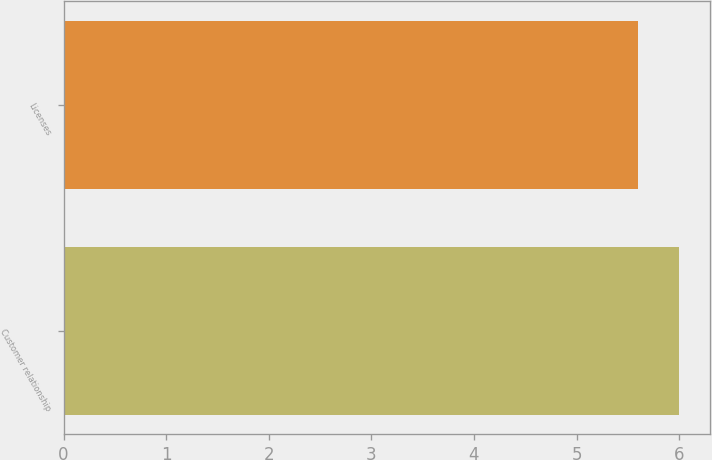Convert chart to OTSL. <chart><loc_0><loc_0><loc_500><loc_500><bar_chart><fcel>Customer relationship<fcel>Licenses<nl><fcel>6<fcel>5.6<nl></chart> 